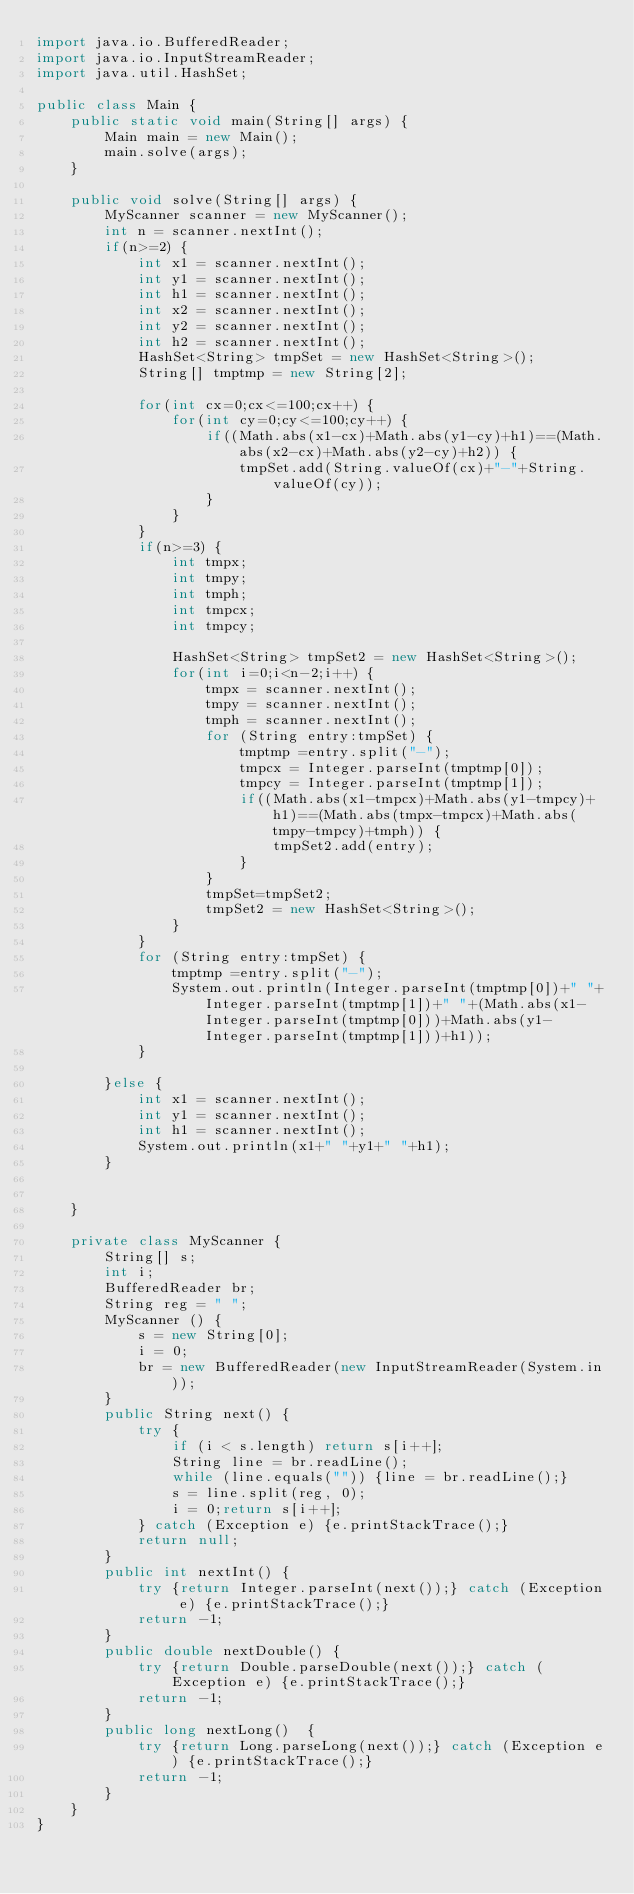<code> <loc_0><loc_0><loc_500><loc_500><_Java_>import java.io.BufferedReader;
import java.io.InputStreamReader;
import java.util.HashSet;

public class Main {
    public static void main(String[] args) {
        Main main = new Main();
        main.solve(args);
    }

    public void solve(String[] args) {
        MyScanner scanner = new MyScanner();
        int n = scanner.nextInt();
        if(n>=2) {
        	int x1 = scanner.nextInt();
        	int y1 = scanner.nextInt();
        	int h1 = scanner.nextInt();
        	int x2 = scanner.nextInt();
        	int y2 = scanner.nextInt();
        	int h2 = scanner.nextInt();
        	HashSet<String> tmpSet = new HashSet<String>();
        	String[] tmptmp = new String[2];

        	for(int cx=0;cx<=100;cx++) {
        		for(int cy=0;cy<=100;cy++) {
        			if((Math.abs(x1-cx)+Math.abs(y1-cy)+h1)==(Math.abs(x2-cx)+Math.abs(y2-cy)+h2)) {
        				tmpSet.add(String.valueOf(cx)+"-"+String.valueOf(cy));
        			}
        		}
        	}
        	if(n>=3) {
        		int tmpx;
        		int tmpy;
        		int tmph;
        		int tmpcx;
        		int tmpcy;

        		HashSet<String> tmpSet2 = new HashSet<String>();
        		for(int i=0;i<n-2;i++) {
        			tmpx = scanner.nextInt();
        			tmpy = scanner.nextInt();
        			tmph = scanner.nextInt();
        			for (String entry:tmpSet) {
        				tmptmp =entry.split("-");
        				tmpcx = Integer.parseInt(tmptmp[0]);
        				tmpcy = Integer.parseInt(tmptmp[1]);
        				if((Math.abs(x1-tmpcx)+Math.abs(y1-tmpcy)+h1)==(Math.abs(tmpx-tmpcx)+Math.abs(tmpy-tmpcy)+tmph)) {
        					tmpSet2.add(entry);
        				}
        			}
        			tmpSet=tmpSet2;
        			tmpSet2 = new HashSet<String>();
        		}
        	}
        	for (String entry:tmpSet) {
        		tmptmp =entry.split("-");
        		System.out.println(Integer.parseInt(tmptmp[0])+" "+Integer.parseInt(tmptmp[1])+" "+(Math.abs(x1-Integer.parseInt(tmptmp[0]))+Math.abs(y1-Integer.parseInt(tmptmp[1]))+h1));
        	}

        }else {
        	int x1 = scanner.nextInt();
        	int y1 = scanner.nextInt();
        	int h1 = scanner.nextInt();
        	System.out.println(x1+" "+y1+" "+h1);
        }


    }

    private class MyScanner {
        String[] s;
        int i;
        BufferedReader br;
        String reg = " ";
        MyScanner () {
            s = new String[0];
            i = 0;
            br = new BufferedReader(new InputStreamReader(System.in));
        }
        public String next() {
            try {
                if (i < s.length) return s[i++];
                String line = br.readLine();
                while (line.equals("")) {line = br.readLine();}
                s = line.split(reg, 0);
                i = 0;return s[i++];
            } catch (Exception e) {e.printStackTrace();}
            return null;
        }
        public int nextInt() {
            try {return Integer.parseInt(next());} catch (Exception e) {e.printStackTrace();}
            return -1;
        }
        public double nextDouble() {
            try {return Double.parseDouble(next());} catch (Exception e) {e.printStackTrace();}
            return -1;
        }
        public long nextLong()  {
            try {return Long.parseLong(next());} catch (Exception e) {e.printStackTrace();}
            return -1;
        }
    }
}</code> 